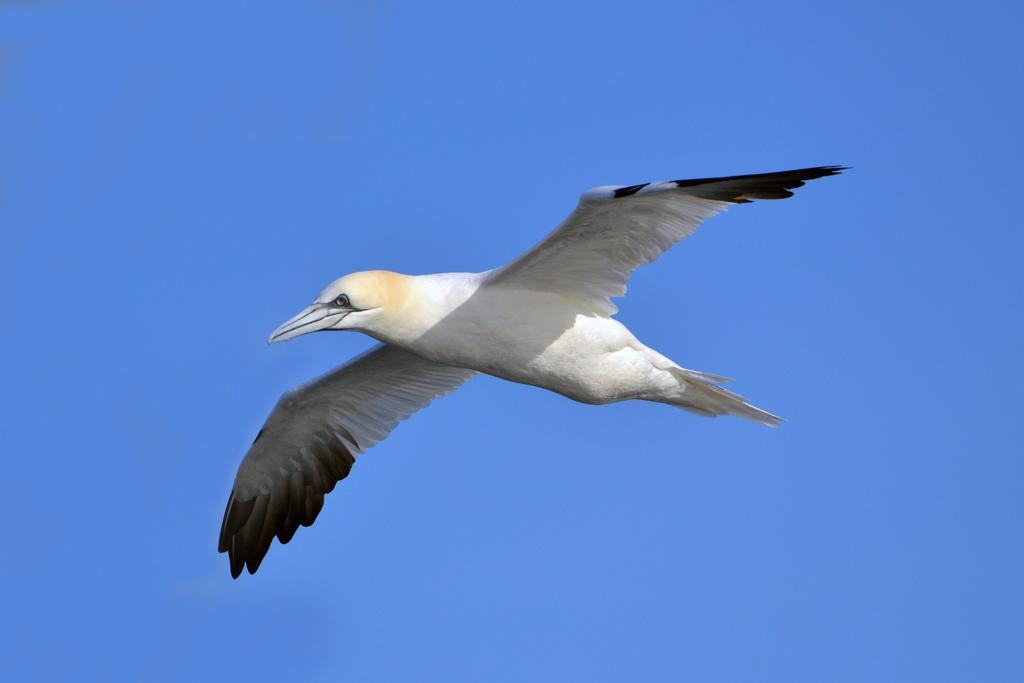How would you summarize this image in a sentence or two? In this picture we can see a bird flying in the air. In the background we can see a clear blue sky. 